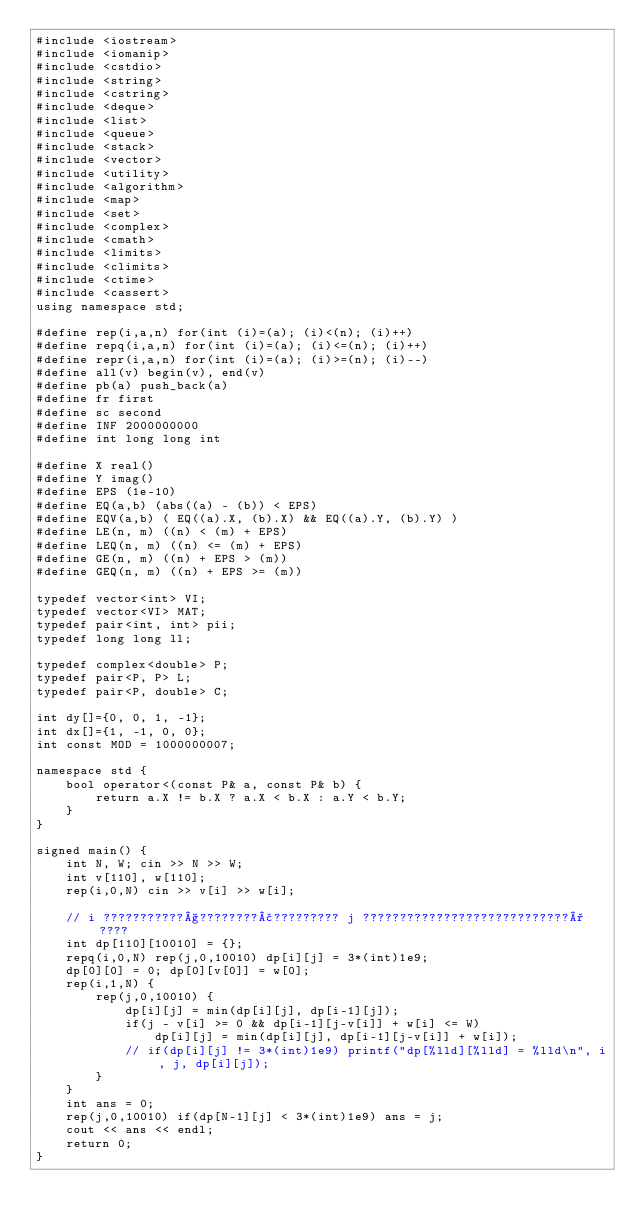Convert code to text. <code><loc_0><loc_0><loc_500><loc_500><_C++_>#include <iostream>
#include <iomanip>
#include <cstdio>
#include <string>
#include <cstring>
#include <deque>
#include <list>
#include <queue>
#include <stack>
#include <vector>
#include <utility>
#include <algorithm>
#include <map>
#include <set>
#include <complex>
#include <cmath>
#include <limits>
#include <climits>
#include <ctime>
#include <cassert>
using namespace std;

#define rep(i,a,n) for(int (i)=(a); (i)<(n); (i)++)
#define repq(i,a,n) for(int (i)=(a); (i)<=(n); (i)++)
#define repr(i,a,n) for(int (i)=(a); (i)>=(n); (i)--)
#define all(v) begin(v), end(v)
#define pb(a) push_back(a)
#define fr first
#define sc second
#define INF 2000000000
#define int long long int

#define X real()
#define Y imag()
#define EPS (1e-10)
#define EQ(a,b) (abs((a) - (b)) < EPS)
#define EQV(a,b) ( EQ((a).X, (b).X) && EQ((a).Y, (b).Y) )
#define LE(n, m) ((n) < (m) + EPS)
#define LEQ(n, m) ((n) <= (m) + EPS)
#define GE(n, m) ((n) + EPS > (m))
#define GEQ(n, m) ((n) + EPS >= (m))

typedef vector<int> VI;
typedef vector<VI> MAT;
typedef pair<int, int> pii;
typedef long long ll;

typedef complex<double> P;
typedef pair<P, P> L;
typedef pair<P, double> C;

int dy[]={0, 0, 1, -1};
int dx[]={1, -1, 0, 0};
int const MOD = 1000000007;

namespace std {
    bool operator<(const P& a, const P& b) {
        return a.X != b.X ? a.X < b.X : a.Y < b.Y;
    }
}

signed main() {
    int N, W; cin >> N >> W;
    int v[110], w[110];
    rep(i,0,N) cin >> v[i] >> w[i];

    // i ???????????§????????£????????? j ????????????????????????????°????
    int dp[110][10010] = {};
    repq(i,0,N) rep(j,0,10010) dp[i][j] = 3*(int)1e9;
    dp[0][0] = 0; dp[0][v[0]] = w[0];
    rep(i,1,N) {
        rep(j,0,10010) {
            dp[i][j] = min(dp[i][j], dp[i-1][j]);
            if(j - v[i] >= 0 && dp[i-1][j-v[i]] + w[i] <= W)
                dp[i][j] = min(dp[i][j], dp[i-1][j-v[i]] + w[i]);
            // if(dp[i][j] != 3*(int)1e9) printf("dp[%lld][%lld] = %lld\n", i, j, dp[i][j]);
        }
    }
    int ans = 0;
    rep(j,0,10010) if(dp[N-1][j] < 3*(int)1e9) ans = j;
    cout << ans << endl;
    return 0;
}</code> 